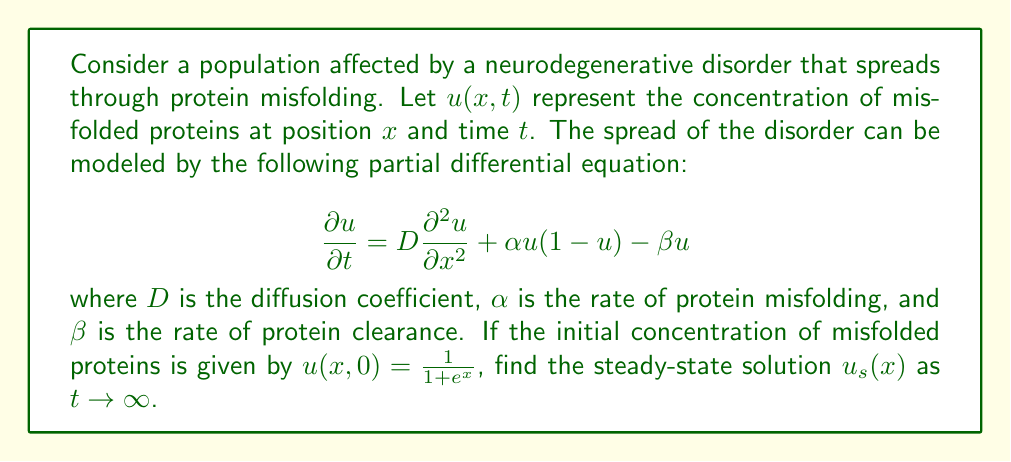Solve this math problem. To find the steady-state solution, we follow these steps:

1) In steady-state, the concentration doesn't change with time, so $\frac{\partial u}{\partial t} = 0$. This gives us:

   $$0 = D\frac{d^2 u_s}{dx^2} + \alpha u_s(1-u_s) - \beta u_s$$

2) We can simplify this equation:

   $$D\frac{d^2 u_s}{dx^2} + (\alpha - \beta)u_s - \alpha u_s^2 = 0$$

3) This is a second-order nonlinear differential equation. To solve it, we can use the method of phase plane analysis. Let $v = \frac{du_s}{dx}$. Then:

   $$\frac{dv}{dx} = \frac{d^2u_s}{dx^2} = \frac{1}{D}[-(\alpha - \beta)u_s + \alpha u_s^2]$$

4) In the phase plane $(u_s, v)$, the equilibrium points are found by setting $v = 0$ and $\frac{dv}{dx} = 0$:

   $$u_s = 0 \text{ or } u_s = 1 - \frac{\beta}{\alpha}$$

5) The non-zero equilibrium point $u_s = 1 - \frac{\beta}{\alpha}$ represents the steady-state solution we're looking for, as it's the non-trivial solution that balances protein misfolding and clearance.

6) This solution is biologically meaningful only if $0 < 1 - \frac{\beta}{\alpha} < 1$, which implies $0 < \beta < \alpha$.

Therefore, the steady-state solution is a constant concentration across all positions $x$:

$$u_s(x) = 1 - \frac{\beta}{\alpha}$$

This represents the long-term equilibrium concentration of misfolded proteins in the population, determined by the balance between the rates of protein misfolding and clearance.
Answer: $u_s(x) = 1 - \frac{\beta}{\alpha}$ 